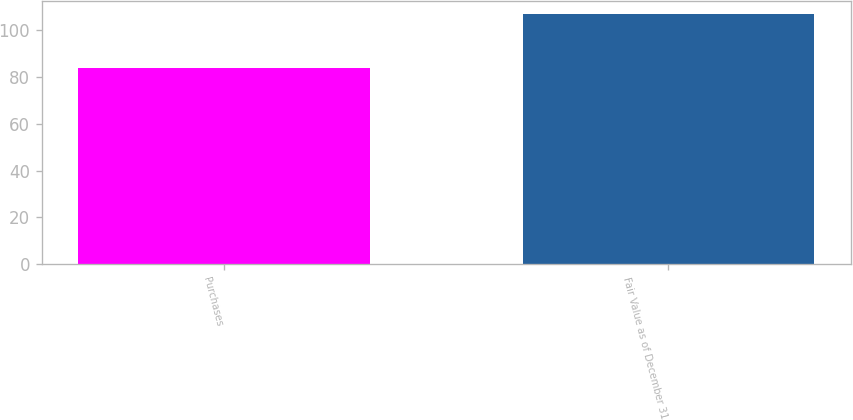Convert chart to OTSL. <chart><loc_0><loc_0><loc_500><loc_500><bar_chart><fcel>Purchases<fcel>Fair Value as of December 31<nl><fcel>84<fcel>107<nl></chart> 